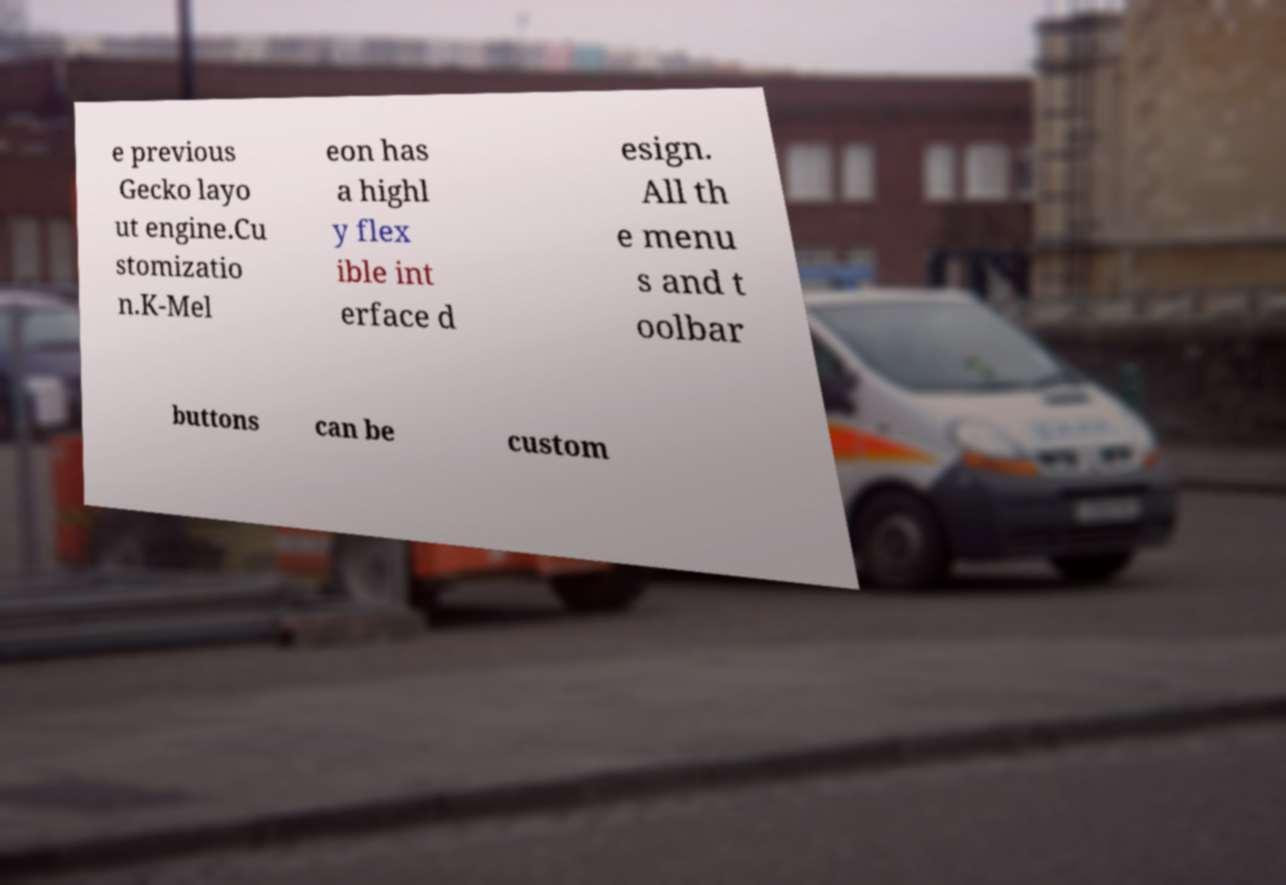Please read and relay the text visible in this image. What does it say? e previous Gecko layo ut engine.Cu stomizatio n.K-Mel eon has a highl y flex ible int erface d esign. All th e menu s and t oolbar buttons can be custom 